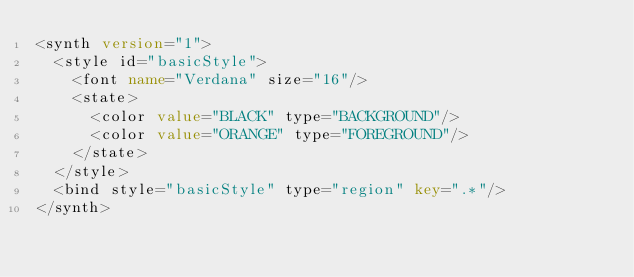<code> <loc_0><loc_0><loc_500><loc_500><_XML_><synth version="1">
  <style id="basicStyle">
    <font name="Verdana" size="16"/>
    <state>
      <color value="BLACK" type="BACKGROUND"/>
      <color value="ORANGE" type="FOREGROUND"/>
    </state>
  </style>
  <bind style="basicStyle" type="region" key=".*"/>
</synth>
</code> 